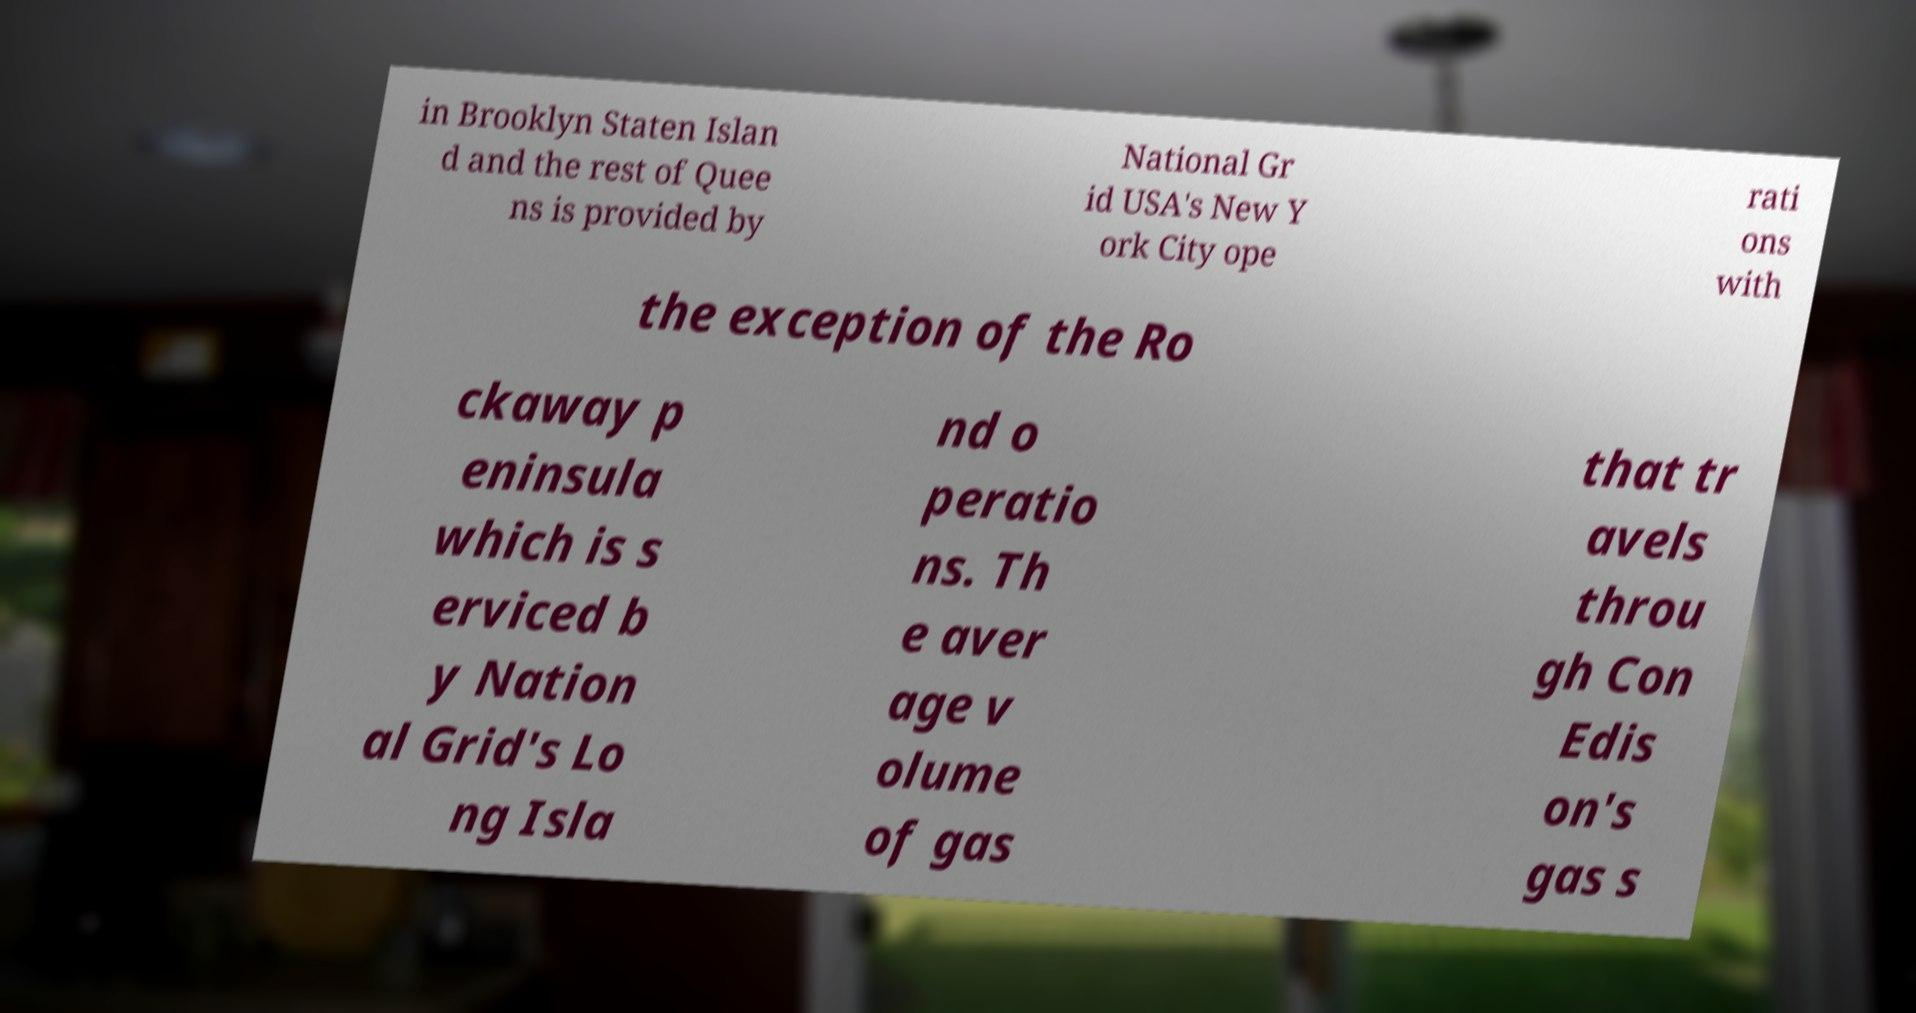Please identify and transcribe the text found in this image. in Brooklyn Staten Islan d and the rest of Quee ns is provided by National Gr id USA's New Y ork City ope rati ons with the exception of the Ro ckaway p eninsula which is s erviced b y Nation al Grid's Lo ng Isla nd o peratio ns. Th e aver age v olume of gas that tr avels throu gh Con Edis on's gas s 